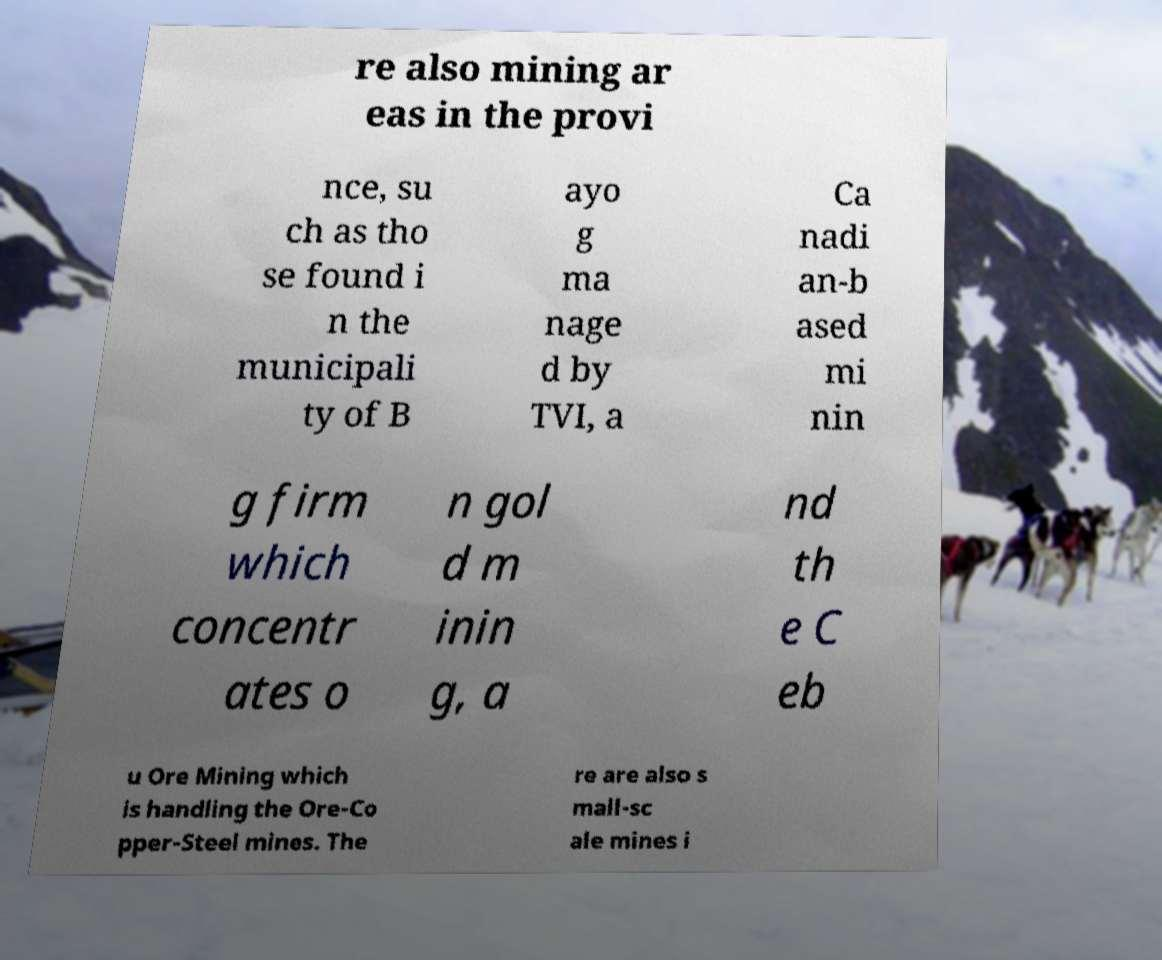Could you extract and type out the text from this image? re also mining ar eas in the provi nce, su ch as tho se found i n the municipali ty of B ayo g ma nage d by TVI, a Ca nadi an-b ased mi nin g firm which concentr ates o n gol d m inin g, a nd th e C eb u Ore Mining which is handling the Ore-Co pper-Steel mines. The re are also s mall-sc ale mines i 